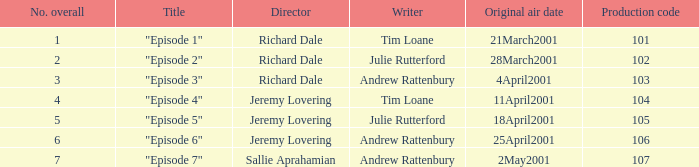What is the top production code of an episode penned by tim loane? 104.0. 